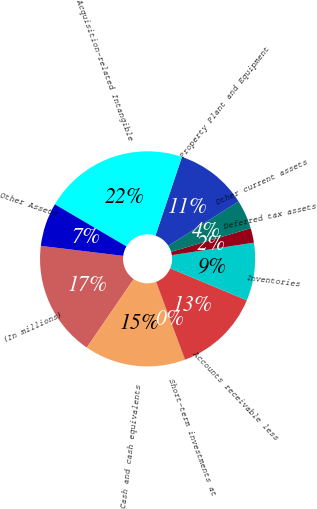Convert chart. <chart><loc_0><loc_0><loc_500><loc_500><pie_chart><fcel>(In millions)<fcel>Cash and cash equivalents<fcel>Short-term investments at<fcel>Accounts receivable less<fcel>Inventories<fcel>Deferred tax assets<fcel>Other current assets<fcel>Property Plant and Equipment<fcel>Acquisition-related Intangible<fcel>Other Assets<nl><fcel>17.37%<fcel>15.2%<fcel>0.02%<fcel>13.04%<fcel>8.7%<fcel>2.19%<fcel>4.36%<fcel>10.87%<fcel>21.71%<fcel>6.53%<nl></chart> 